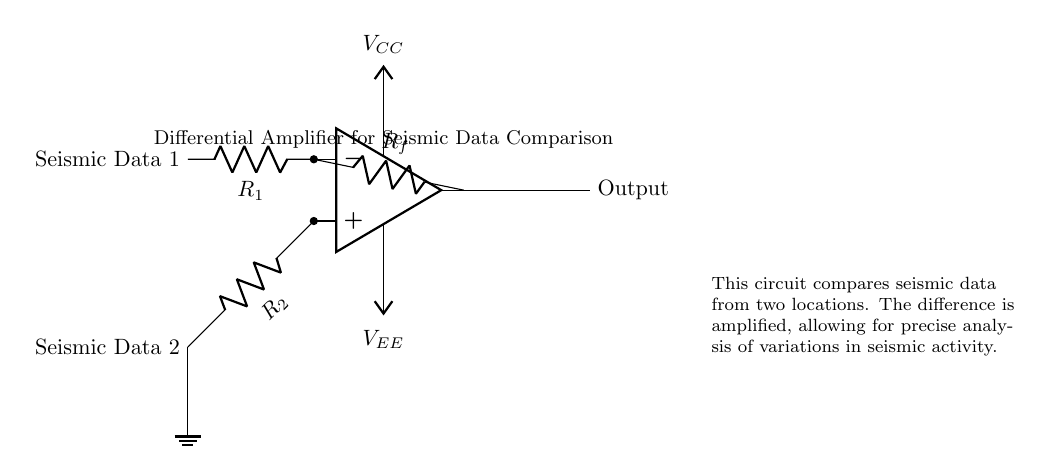What type of amplifier is shown in the circuit? The circuit is labeled as a differential amplifier, which is designed to amplify the difference between two input signals.
Answer: Differential amplifier What are the values of the resistors used in this circuit? The labels on the resistors indicate their names: R1, R2, and Rf, but the actual numerical values are not specified in the diagram.
Answer: R1, R2, Rf How many input signals does this amplifier compare? The circuit diagram shows two input signals labeled as Seismic Data 1 and Seismic Data 2, which the amplifier is comparing.
Answer: Two What does the output of the amplifier represent? The output represents the amplified difference between the two input seismic data signals, facilitating analysis of seismic activity variations.
Answer: Amplified difference Why is the feedback resistor important in this circuit? The feedback resistor (Rf) is crucial for setting the gain of the amplifier, which determines how much the input difference will be amplified in the output.
Answer: Gain control What is the purpose of the ground connection in this circuit? The ground connection provides a reference point for the voltage levels in the circuit, ensuring stable operation of the amplifier by completing the circuit path.
Answer: Reference point What do the Vcc and Vee symbols represent in the circuit? Vcc represents the positive supply voltage, while Vee represents the negative supply voltage, both necessary for the operational amplifier to function correctly.
Answer: Power supply voltages 